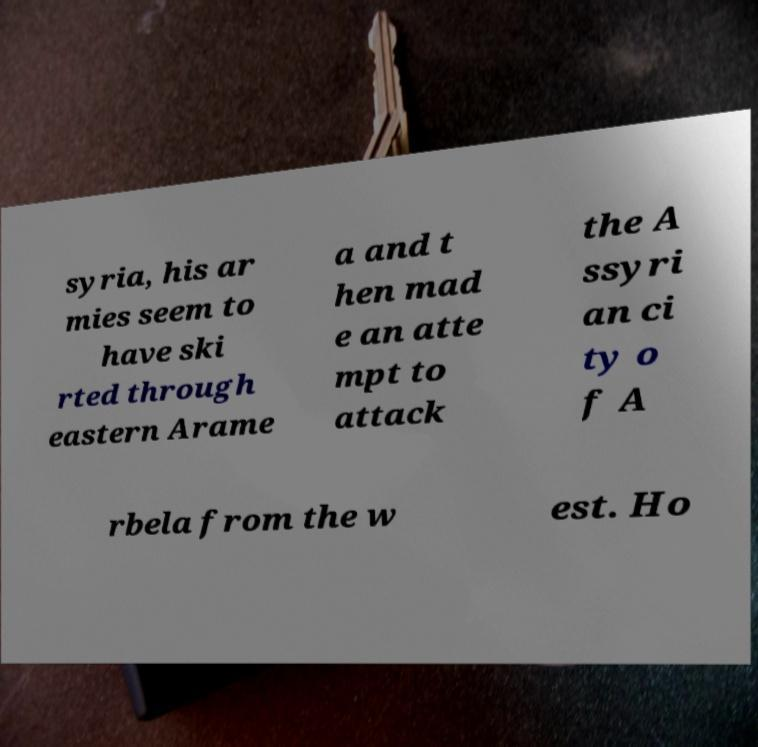Could you extract and type out the text from this image? syria, his ar mies seem to have ski rted through eastern Arame a and t hen mad e an atte mpt to attack the A ssyri an ci ty o f A rbela from the w est. Ho 